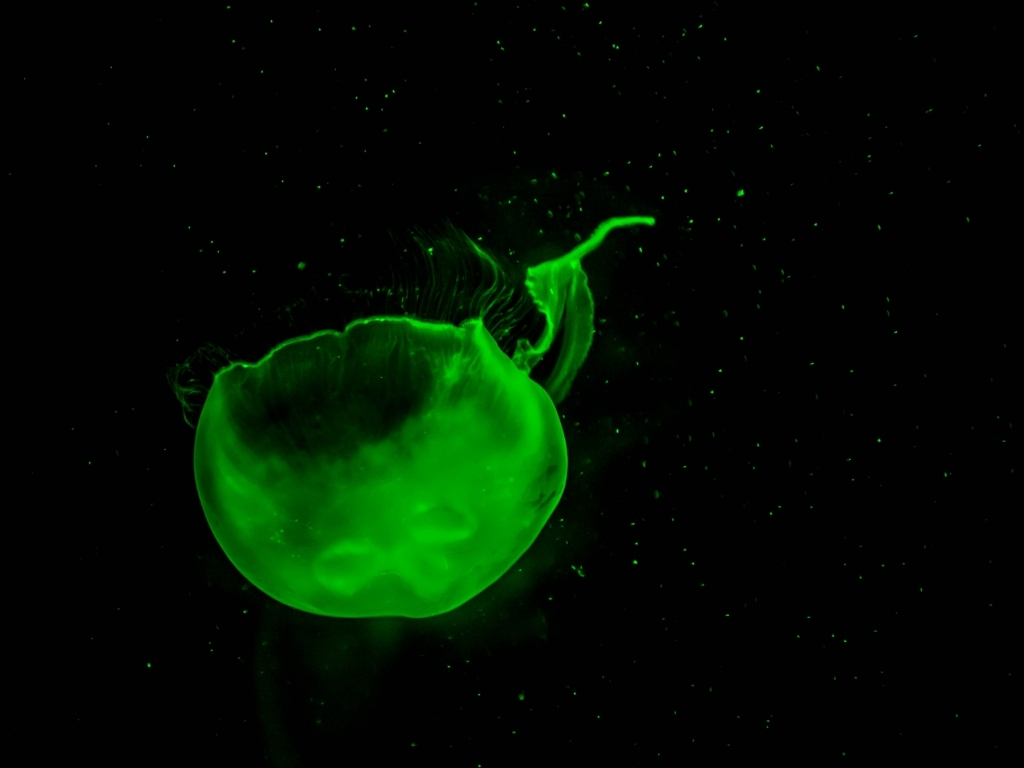Can you describe the creature in the image and explain what makes it glow? The creature in the image is a jellyfish, which appears to be glowing due to bioluminescence. This fascinating biological phenomenon occurs when organisms produce light through a chemical reaction. The luminescence can serve various purposes, such as attracting prey, deterring predators, or finding mates. 